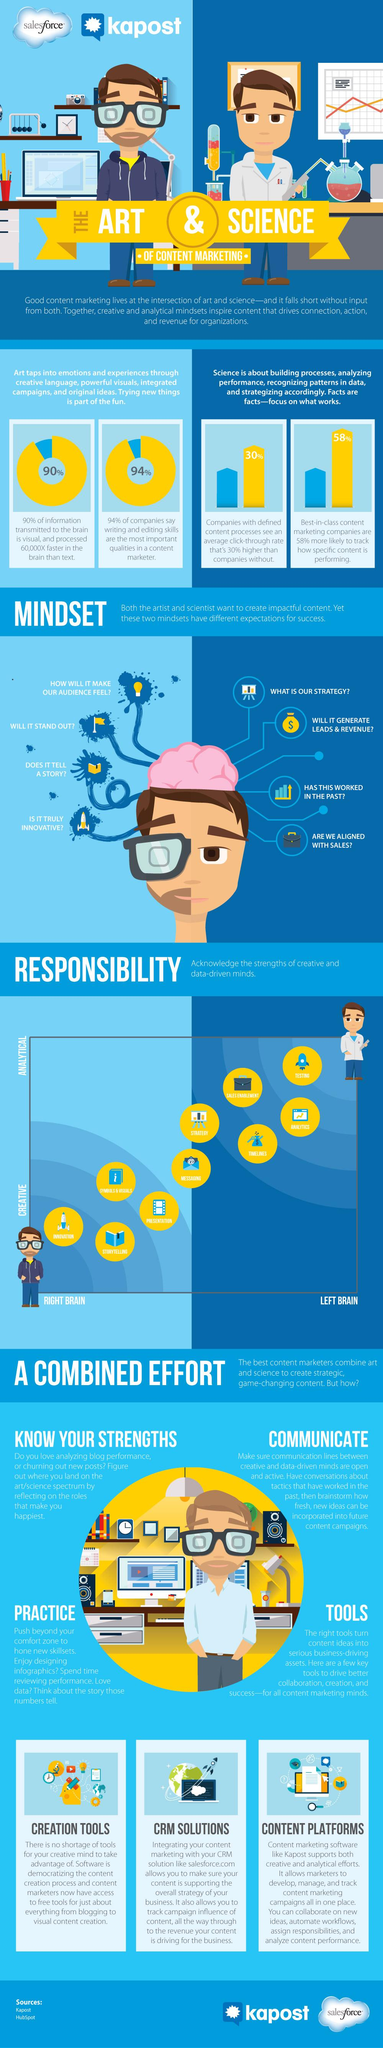Point out several critical features in this image. The light bulb icon is used to explore and examine various topics in content writing, with the intention of providing valuable insights and information to the audience. The use of this icon is expected to engage and enlighten the audience, leading to a positive emotional response. Visual information is processed significantly faster than text, with a difference of 60,000 times. Approximately 10% of the information transmitted to the brain is not visual in nature. The left brain is responsible for exploring the analytical part. The right brain is responsible for exploring and expressing creativity. 